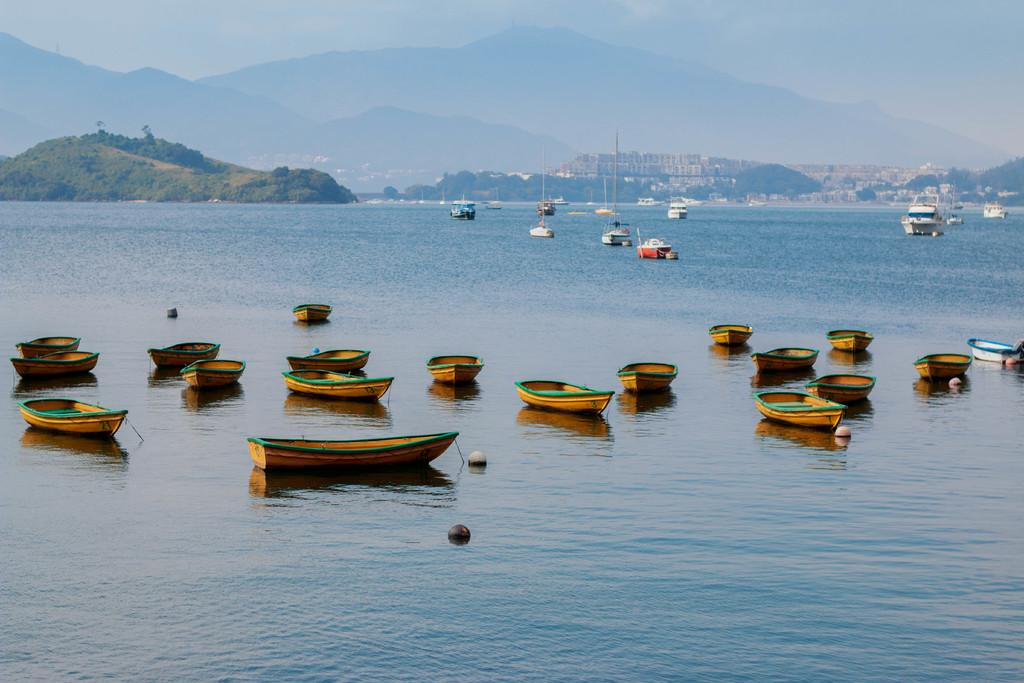What is in the water in the image? There are boats in the water in the image. What objects can be seen in the foreground of the image? There are two balls in the foreground. What structures are visible in the background of the image? There are buildings in the background. What type of natural elements can be seen in the background of the image? Trees, mountains, and the sky are visible in the background. Can you tell me the condition of the playground in the image? There is no playground present in the image. How many times does the person cry in the image? There are no people or crying depicted in the image. 